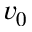Convert formula to latex. <formula><loc_0><loc_0><loc_500><loc_500>v _ { 0 }</formula> 